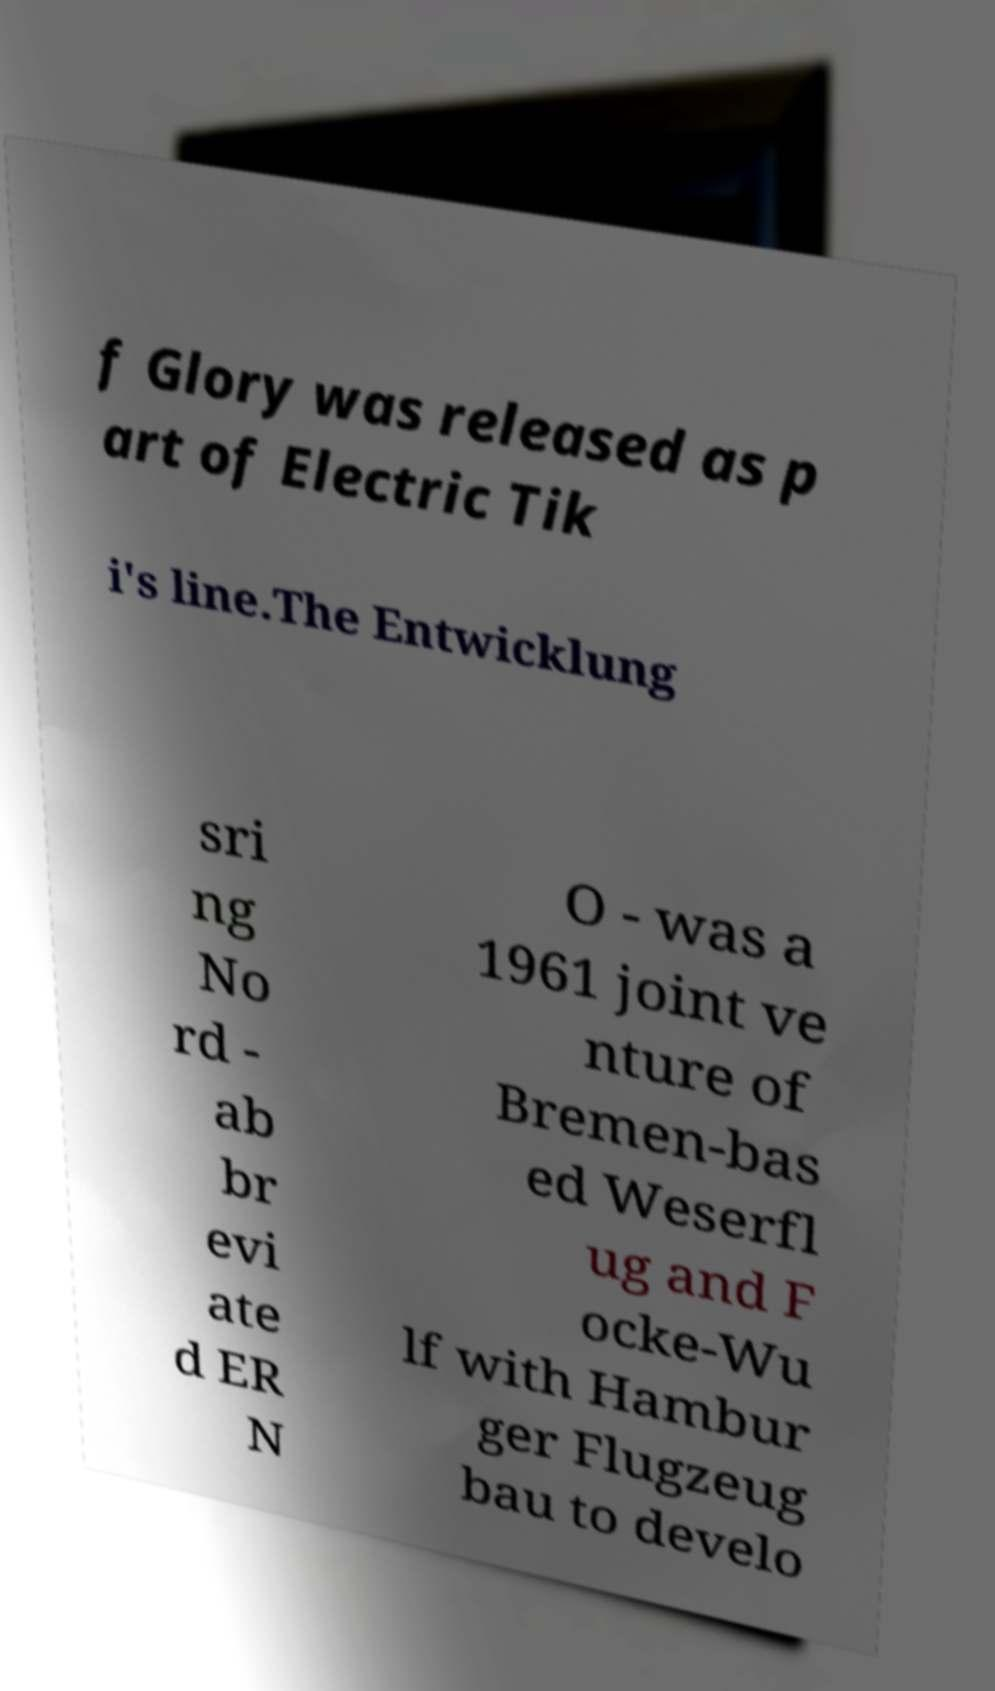There's text embedded in this image that I need extracted. Can you transcribe it verbatim? f Glory was released as p art of Electric Tik i's line.The Entwicklung sri ng No rd - ab br evi ate d ER N O - was a 1961 joint ve nture of Bremen-bas ed Weserfl ug and F ocke-Wu lf with Hambur ger Flugzeug bau to develo 